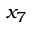Convert formula to latex. <formula><loc_0><loc_0><loc_500><loc_500>x _ { 7 }</formula> 